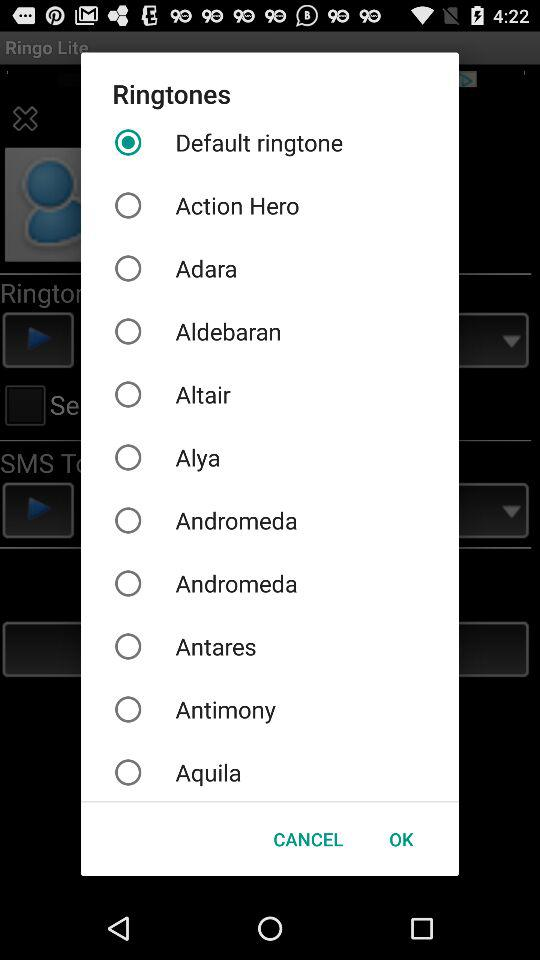What is the selected ringtone? The selected ringtone is "Default ringtone". 